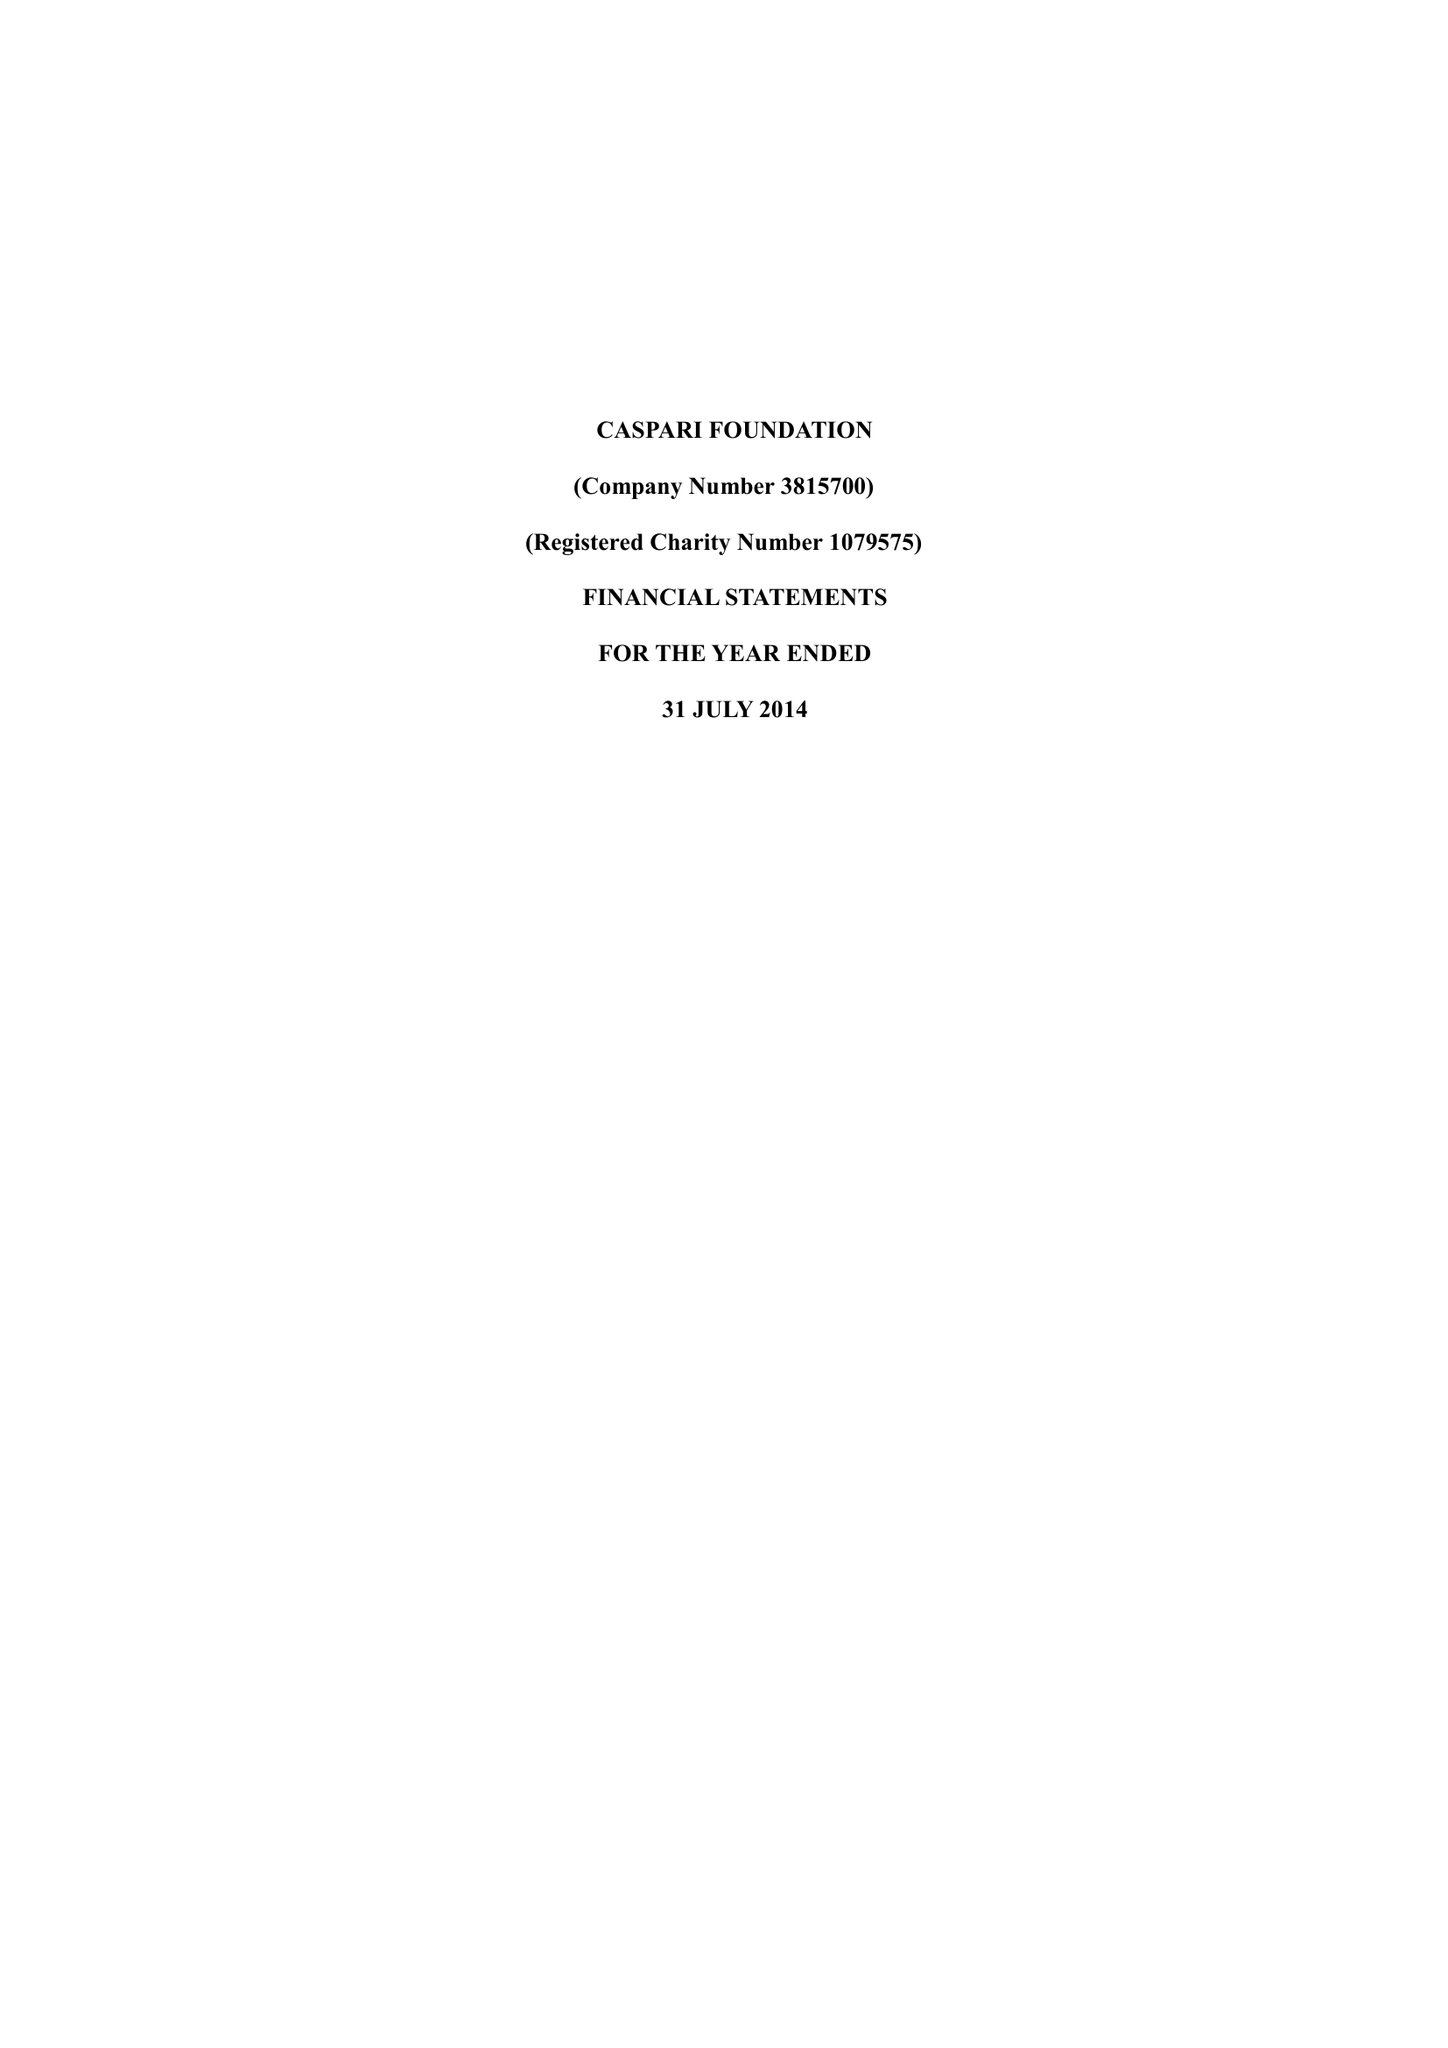What is the value for the address__post_town?
Answer the question using a single word or phrase. LONDON 